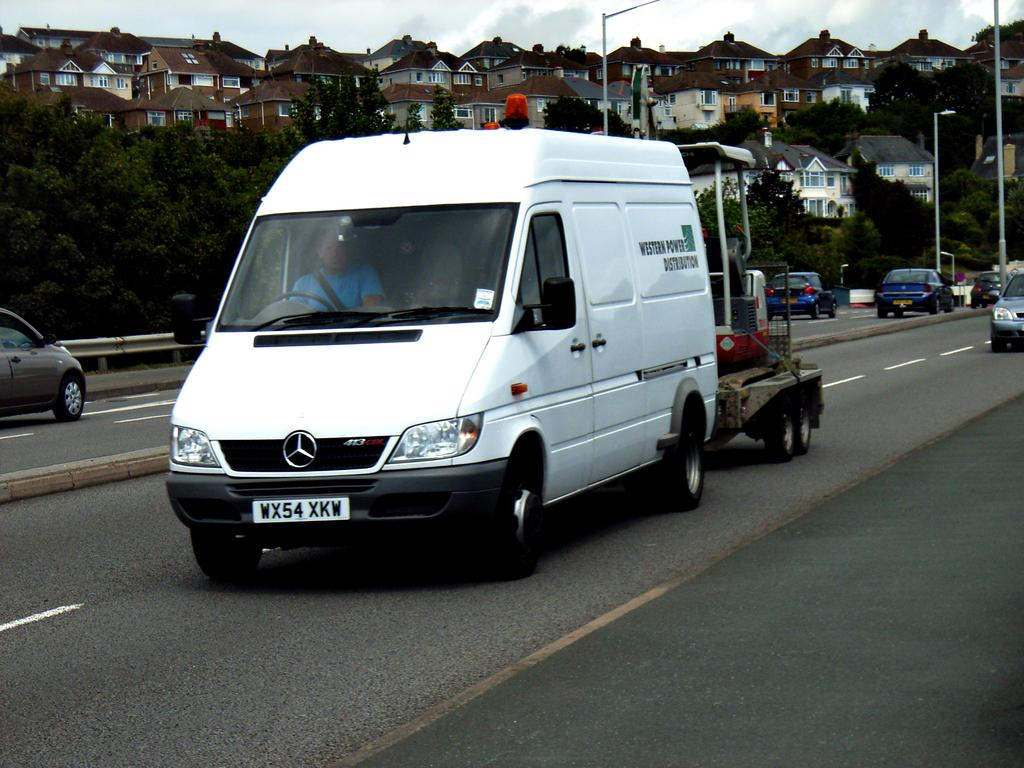What is happening on the road in the image? There are vehicles moving on the road in the image. What type of structures can be seen in the image? There are houses visible in the image. What type of vegetation is present in the image? There are trees in the image. What type of oil is being extracted from the trees in the image? There is no oil extraction process depicted in the image; it features vehicles moving on the road, houses, and trees. Where is the hall located in the image? There is no hall present in the image. 